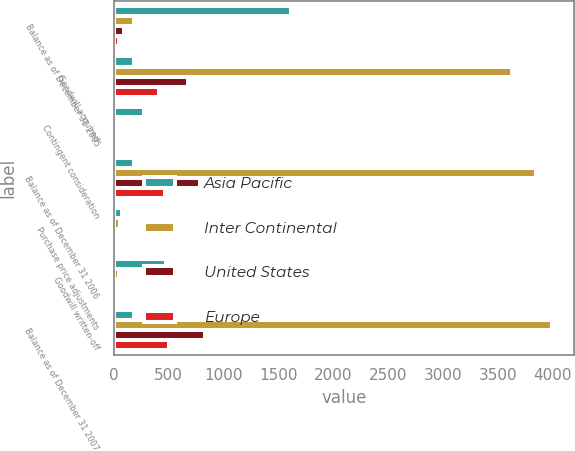Convert chart. <chart><loc_0><loc_0><loc_500><loc_500><stacked_bar_chart><ecel><fcel>Balance as of December 31 2005<fcel>Goodwill acquired<fcel>Contingent consideration<fcel>Balance as of December 31 2006<fcel>Purchase price adjustments<fcel>Goodwill written-off<fcel>Balance as of December 31 2007<nl><fcel>Asia Pacific<fcel>1613<fcel>182<fcel>278<fcel>182<fcel>77<fcel>478<fcel>182<nl><fcel>Inter Continental<fcel>182<fcel>3626<fcel>39<fcel>3847<fcel>53<fcel>43<fcel>3996<nl><fcel>United States<fcel>97<fcel>674<fcel>13<fcel>784<fcel>8<fcel>18<fcel>832<nl><fcel>Europe<fcel>46<fcel>412<fcel>10<fcel>468<fcel>4<fcel>13<fcel>502<nl></chart> 